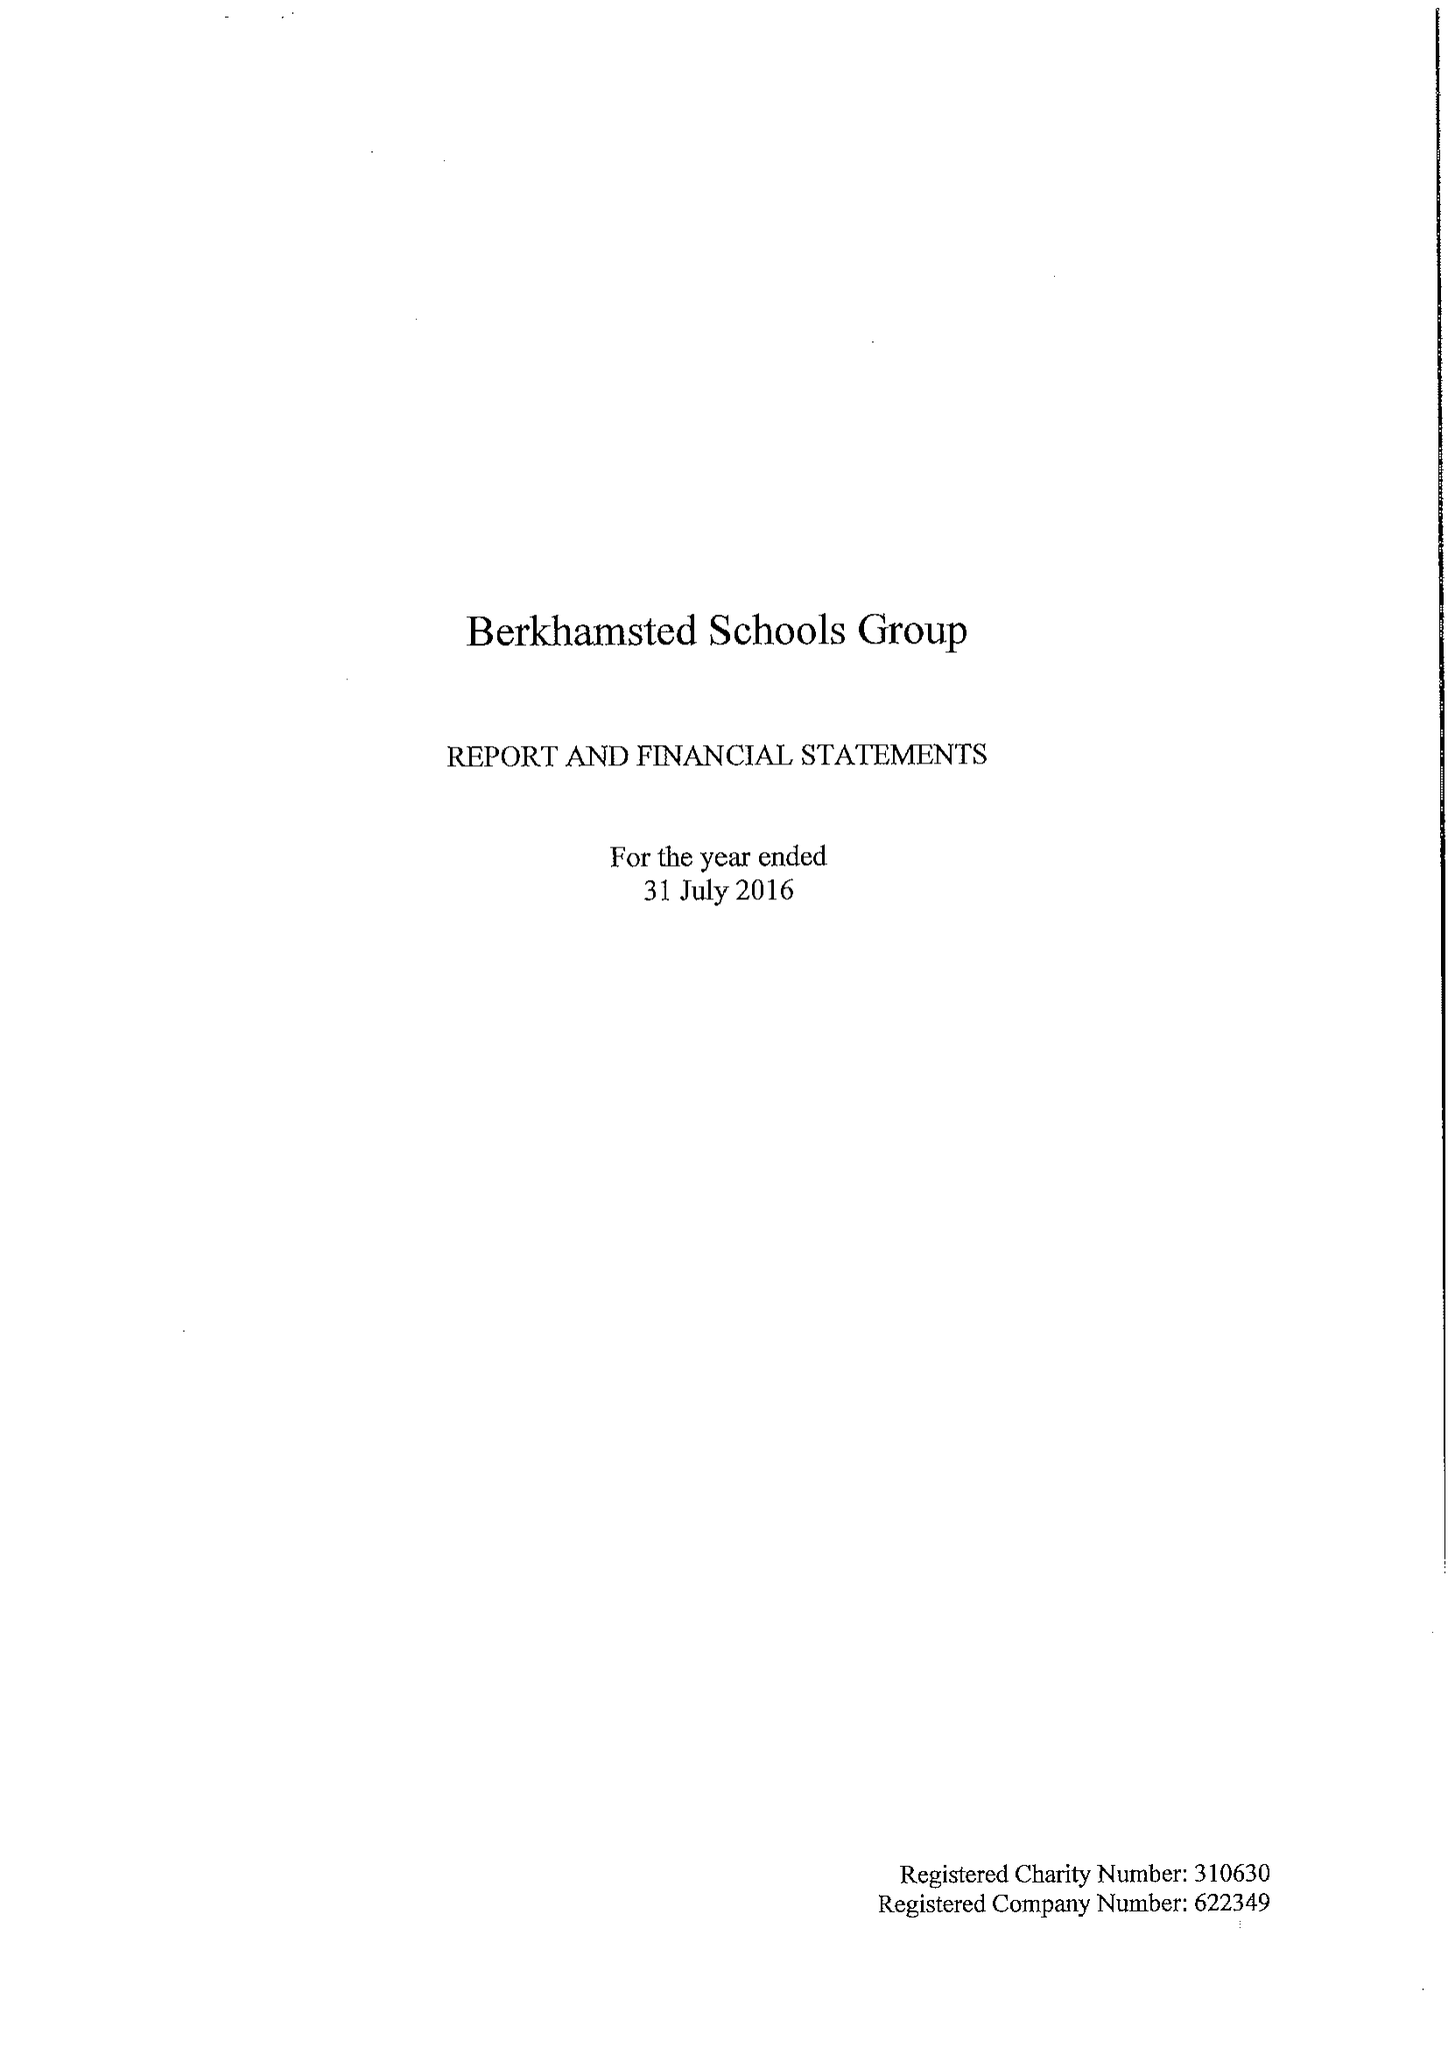What is the value for the income_annually_in_british_pounds?
Answer the question using a single word or phrase. 29769000.00 